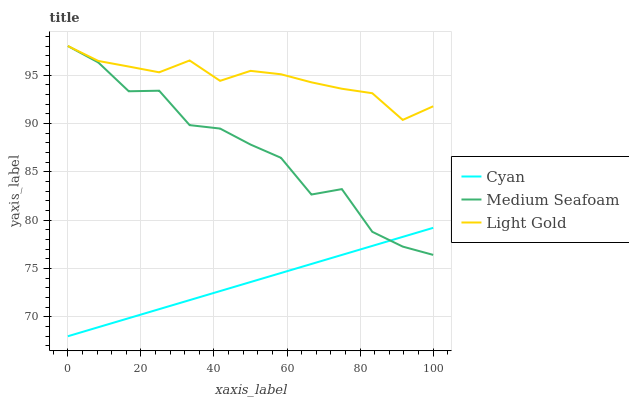Does Cyan have the minimum area under the curve?
Answer yes or no. Yes. Does Light Gold have the maximum area under the curve?
Answer yes or no. Yes. Does Medium Seafoam have the minimum area under the curve?
Answer yes or no. No. Does Medium Seafoam have the maximum area under the curve?
Answer yes or no. No. Is Cyan the smoothest?
Answer yes or no. Yes. Is Medium Seafoam the roughest?
Answer yes or no. Yes. Is Light Gold the smoothest?
Answer yes or no. No. Is Light Gold the roughest?
Answer yes or no. No. Does Cyan have the lowest value?
Answer yes or no. Yes. Does Medium Seafoam have the lowest value?
Answer yes or no. No. Does Medium Seafoam have the highest value?
Answer yes or no. Yes. Is Cyan less than Light Gold?
Answer yes or no. Yes. Is Light Gold greater than Cyan?
Answer yes or no. Yes. Does Cyan intersect Medium Seafoam?
Answer yes or no. Yes. Is Cyan less than Medium Seafoam?
Answer yes or no. No. Is Cyan greater than Medium Seafoam?
Answer yes or no. No. Does Cyan intersect Light Gold?
Answer yes or no. No. 